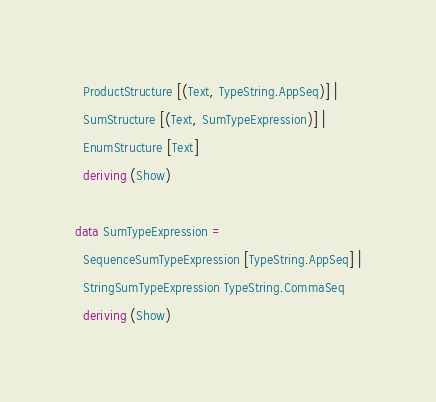Convert code to text. <code><loc_0><loc_0><loc_500><loc_500><_Haskell_>  ProductStructure [(Text, TypeString.AppSeq)] |
  SumStructure [(Text, SumTypeExpression)] |
  EnumStructure [Text]
  deriving (Show)

data SumTypeExpression =
  SequenceSumTypeExpression [TypeString.AppSeq] |
  StringSumTypeExpression TypeString.CommaSeq
  deriving (Show)
</code> 